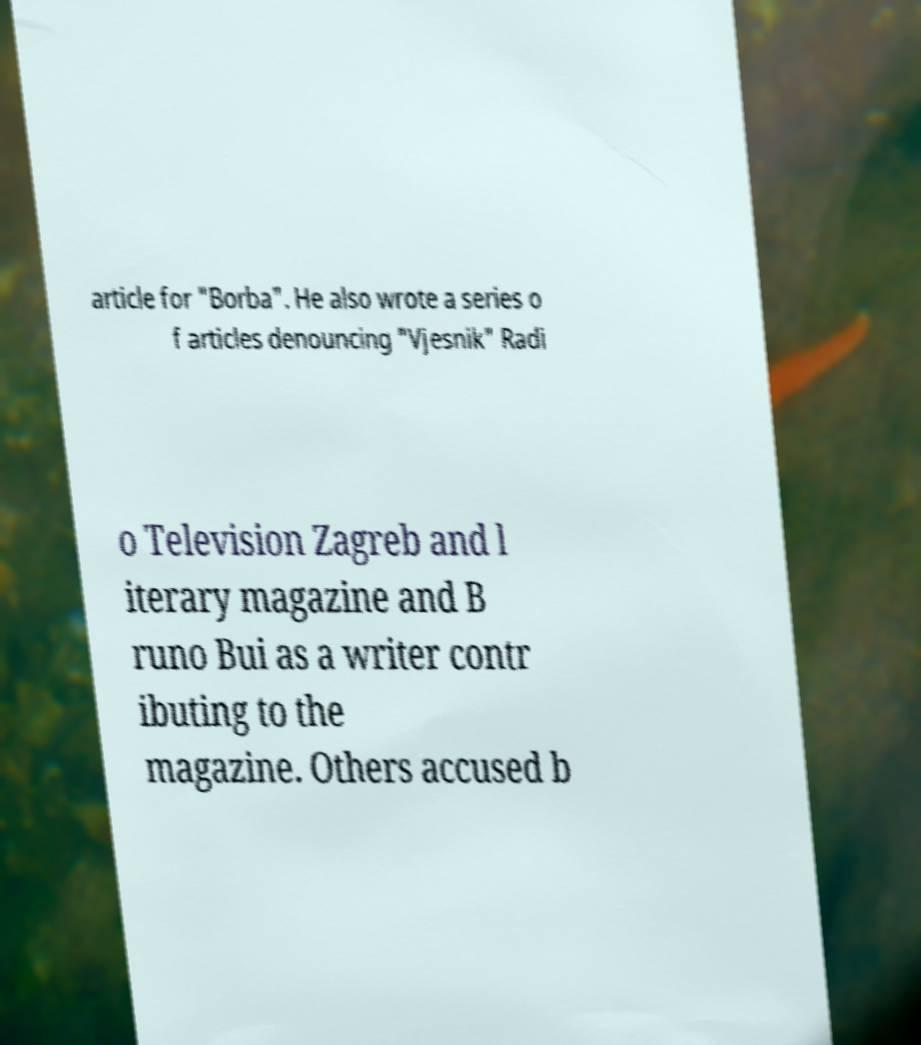There's text embedded in this image that I need extracted. Can you transcribe it verbatim? article for "Borba". He also wrote a series o f articles denouncing "Vjesnik" Radi o Television Zagreb and l iterary magazine and B runo Bui as a writer contr ibuting to the magazine. Others accused b 